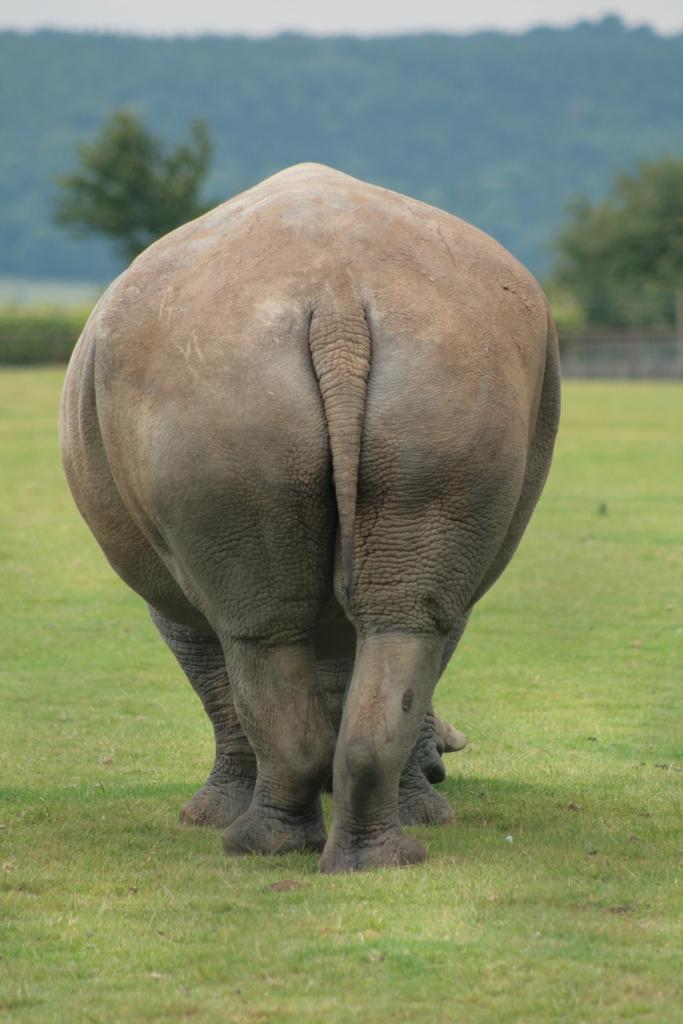What animal is on the ground in the image? There is an elephant on the ground in the image. What type of surface is the elephant standing on? The ground is covered in grass. What can be seen in the background of the image? There are trees and the sky visible in the background of the image. How many wounds can be seen on the elephant in the image? There are no visible wounds on the elephant in the image. What type of stretch is the elephant performing in the image? The elephant is not performing any stretch in the image; it is standing still. 